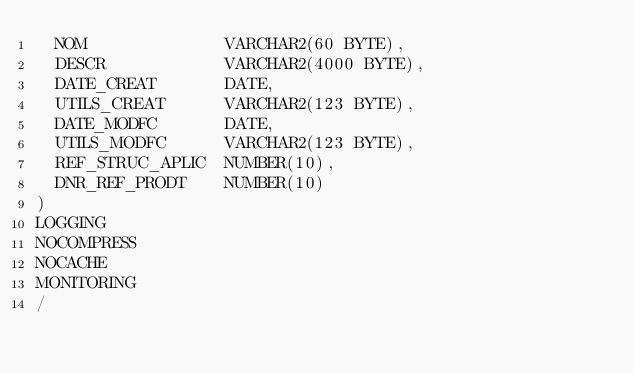Convert code to text. <code><loc_0><loc_0><loc_500><loc_500><_SQL_>  NOM              VARCHAR2(60 BYTE),
  DESCR            VARCHAR2(4000 BYTE),
  DATE_CREAT       DATE,
  UTILS_CREAT      VARCHAR2(123 BYTE),
  DATE_MODFC       DATE,
  UTILS_MODFC      VARCHAR2(123 BYTE),
  REF_STRUC_APLIC  NUMBER(10),
  DNR_REF_PRODT    NUMBER(10)
)
LOGGING 
NOCOMPRESS 
NOCACHE
MONITORING
/
</code> 